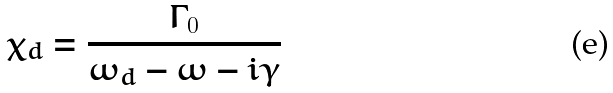Convert formula to latex. <formula><loc_0><loc_0><loc_500><loc_500>\chi _ { d } = \frac { \Gamma _ { 0 } } { \omega _ { d } - \omega - i \gamma }</formula> 